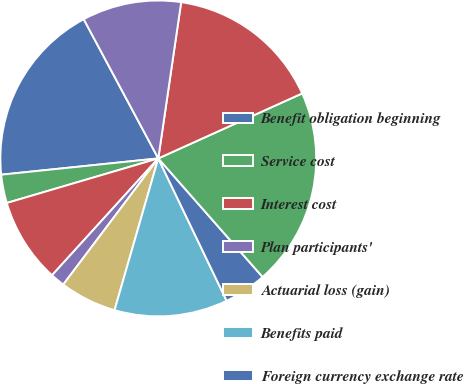<chart> <loc_0><loc_0><loc_500><loc_500><pie_chart><fcel>Benefit obligation beginning<fcel>Service cost<fcel>Interest cost<fcel>Plan participants'<fcel>Actuarial loss (gain)<fcel>Benefits paid<fcel>Foreign currency exchange rate<fcel>Benefit obligation end of<fcel>Fair value of plan assets<fcel>Actual return on plan assets<nl><fcel>18.82%<fcel>2.91%<fcel>8.7%<fcel>1.47%<fcel>5.81%<fcel>11.59%<fcel>4.36%<fcel>20.27%<fcel>15.93%<fcel>10.14%<nl></chart> 